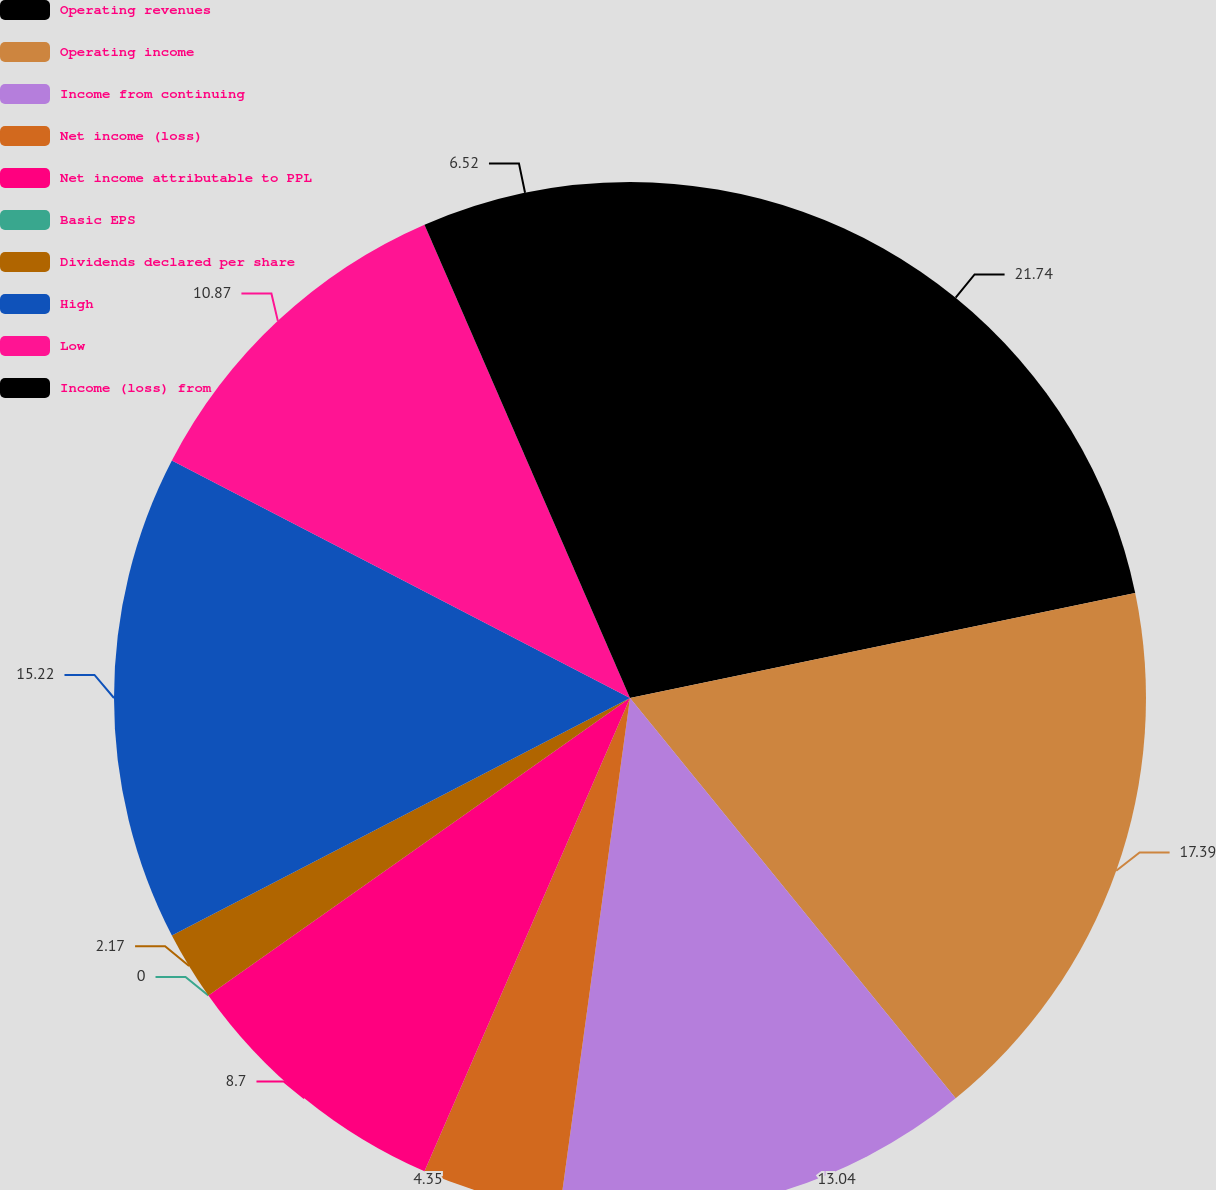Convert chart to OTSL. <chart><loc_0><loc_0><loc_500><loc_500><pie_chart><fcel>Operating revenues<fcel>Operating income<fcel>Income from continuing<fcel>Net income (loss)<fcel>Net income attributable to PPL<fcel>Basic EPS<fcel>Dividends declared per share<fcel>High<fcel>Low<fcel>Income (loss) from<nl><fcel>21.74%<fcel>17.39%<fcel>13.04%<fcel>4.35%<fcel>8.7%<fcel>0.0%<fcel>2.17%<fcel>15.22%<fcel>10.87%<fcel>6.52%<nl></chart> 